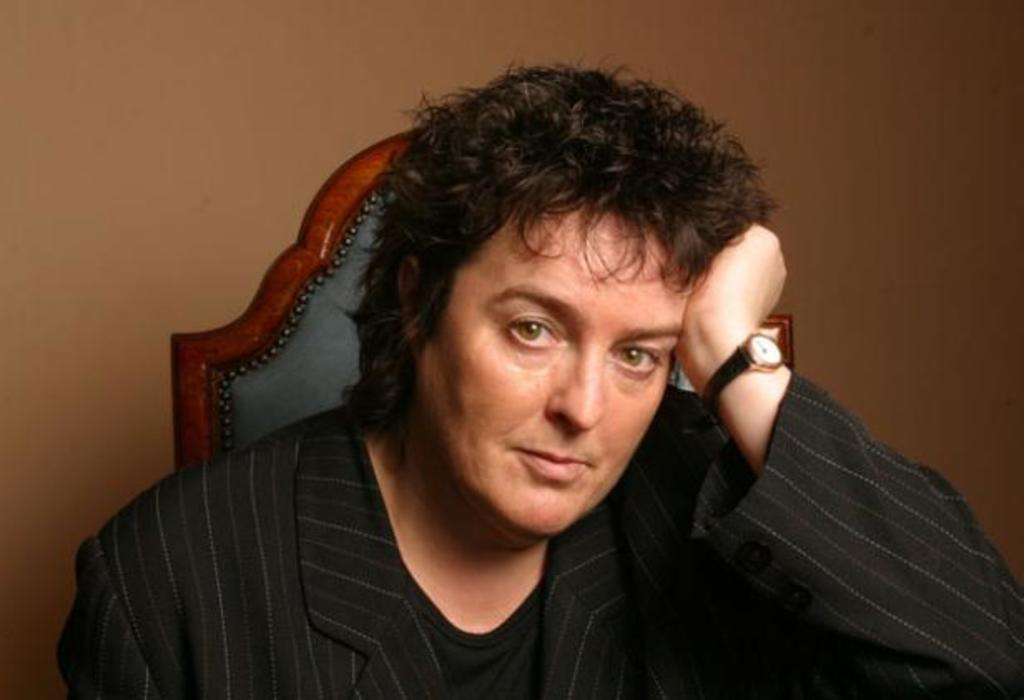Who or what is present in the image? There is a person in the image. What is the person wearing? The person is wearing a black blazer. What is located behind the person? There is a chair behind the person. What is behind the chair? There is a wall behind the chair. What type of shoes is the person wearing in the image? The provided facts do not mention any shoes, so we cannot determine the type of shoes the person is wearing. 